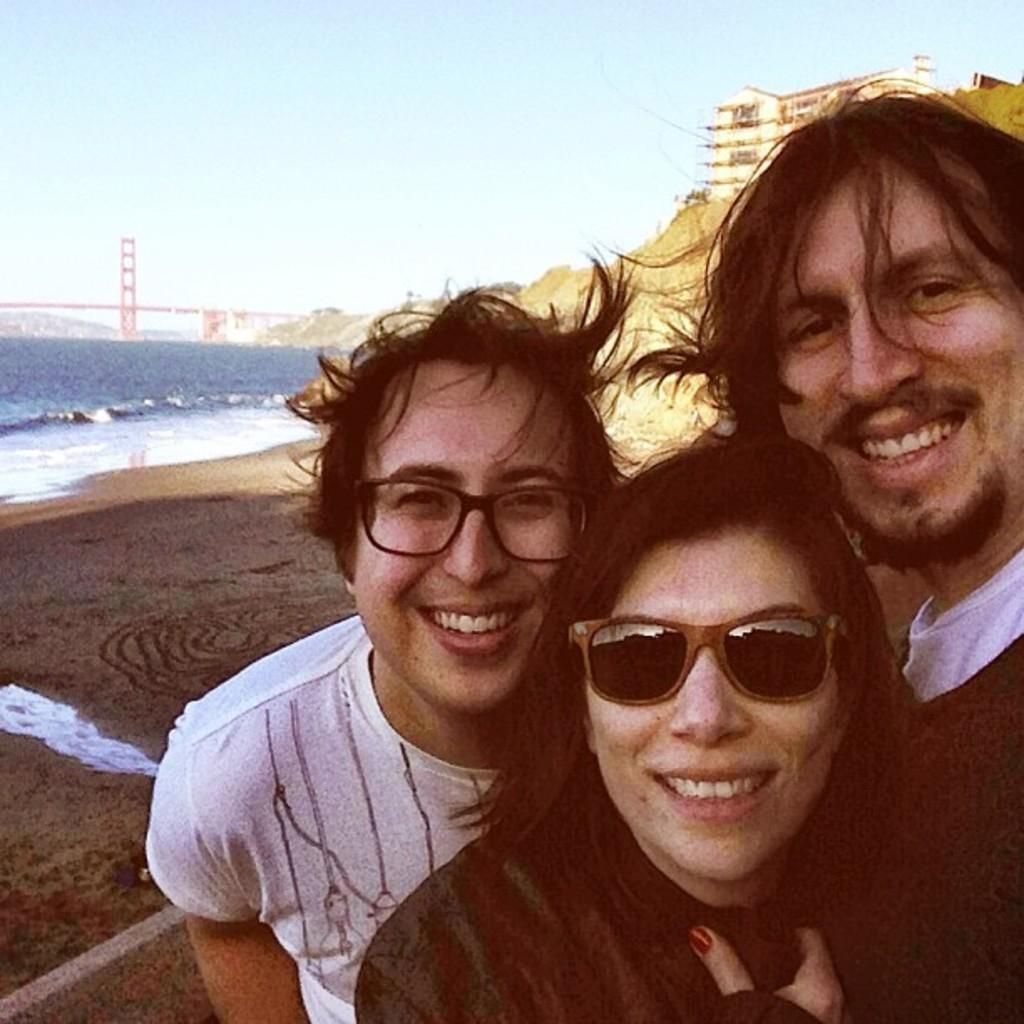How many people are in the image and what are they doing? There are three people standing and smiling in the center of the image. What can be seen on the left side of the image? There is water on the left side of the image, and a bridge is visible in the water. What is visible in the background of the image? There is a building, a hill, and the sky visible in the background of the image. What type of banana is hanging from the bridge in the image? There is no banana present in the image, and therefore no such object can be observed hanging from the bridge. 